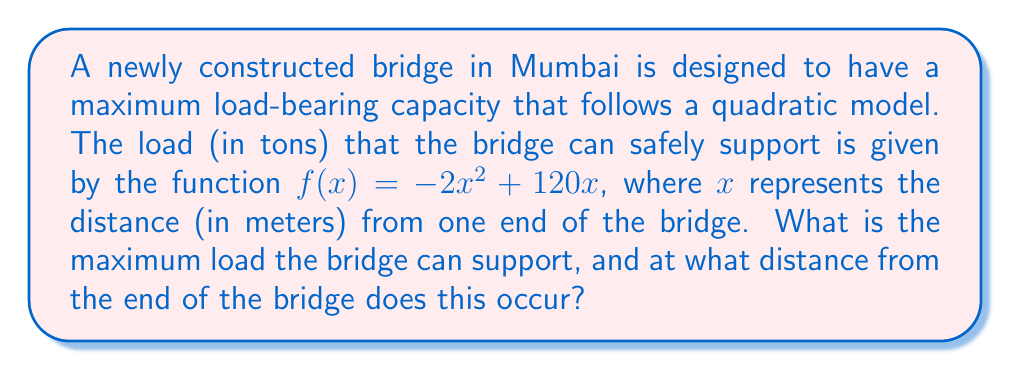Could you help me with this problem? To solve this problem, we'll follow these steps:

1) The function $f(x) = -2x^2 + 120x$ is a quadratic function, and its graph is a parabola that opens downward (because the coefficient of $x^2$ is negative).

2) The maximum point of a parabola occurs at the vertex. For a quadratic function in the form $f(x) = ax^2 + bx + c$, the x-coordinate of the vertex is given by $x = -\frac{b}{2a}$.

3) In our case, $a = -2$ and $b = 120$. Let's calculate the x-coordinate of the vertex:

   $x = -\frac{b}{2a} = -\frac{120}{2(-2)} = -\frac{120}{-4} = 30$

4) This means the maximum load occurs 30 meters from the end of the bridge.

5) To find the maximum load, we need to calculate $f(30)$:

   $f(30) = -2(30)^2 + 120(30)$
   $= -2(900) + 3600$
   $= -1800 + 3600$
   $= 1800$

Therefore, the maximum load the bridge can support is 1800 tons, occurring 30 meters from the end of the bridge.
Answer: 1800 tons at 30 meters 